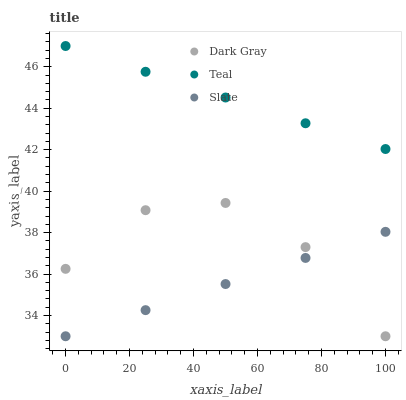Does Slate have the minimum area under the curve?
Answer yes or no. Yes. Does Teal have the maximum area under the curve?
Answer yes or no. Yes. Does Teal have the minimum area under the curve?
Answer yes or no. No. Does Slate have the maximum area under the curve?
Answer yes or no. No. Is Slate the smoothest?
Answer yes or no. Yes. Is Dark Gray the roughest?
Answer yes or no. Yes. Is Teal the roughest?
Answer yes or no. No. Does Dark Gray have the lowest value?
Answer yes or no. Yes. Does Teal have the lowest value?
Answer yes or no. No. Does Teal have the highest value?
Answer yes or no. Yes. Does Slate have the highest value?
Answer yes or no. No. Is Dark Gray less than Teal?
Answer yes or no. Yes. Is Teal greater than Dark Gray?
Answer yes or no. Yes. Does Dark Gray intersect Slate?
Answer yes or no. Yes. Is Dark Gray less than Slate?
Answer yes or no. No. Is Dark Gray greater than Slate?
Answer yes or no. No. Does Dark Gray intersect Teal?
Answer yes or no. No. 